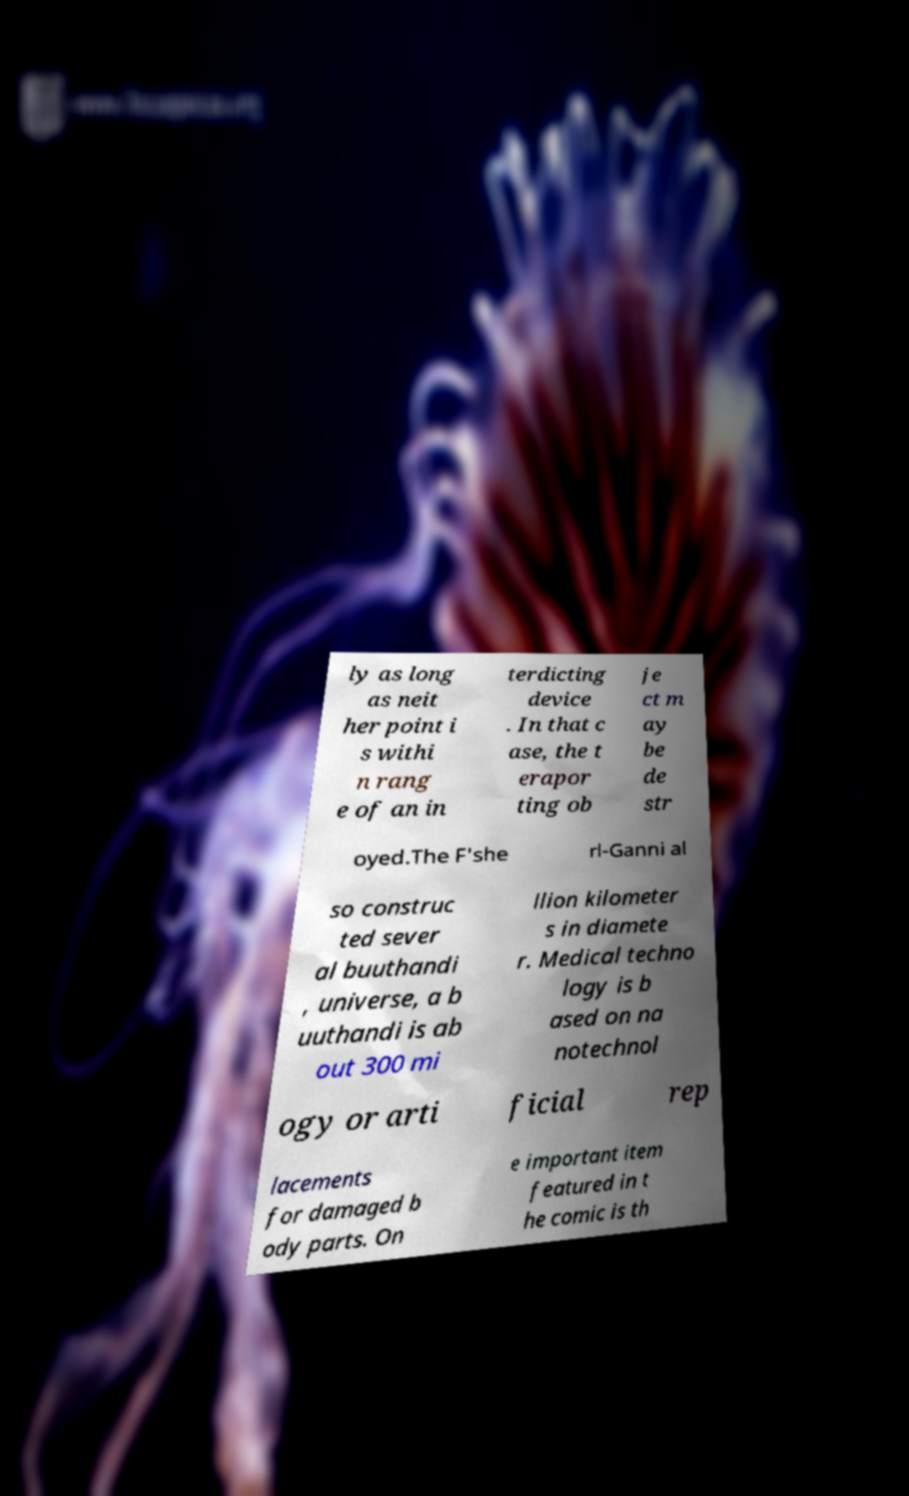Could you extract and type out the text from this image? ly as long as neit her point i s withi n rang e of an in terdicting device . In that c ase, the t erapor ting ob je ct m ay be de str oyed.The F'she rl-Ganni al so construc ted sever al buuthandi , universe, a b uuthandi is ab out 300 mi llion kilometer s in diamete r. Medical techno logy is b ased on na notechnol ogy or arti ficial rep lacements for damaged b ody parts. On e important item featured in t he comic is th 